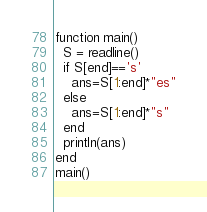Convert code to text. <code><loc_0><loc_0><loc_500><loc_500><_Julia_>function main()
  S = readline()
  if S[end]=='s'
    ans=S[1:end]*"es"
  else
    ans=S[1:end]*"s"
  end
  println(ans)
end
main()
</code> 